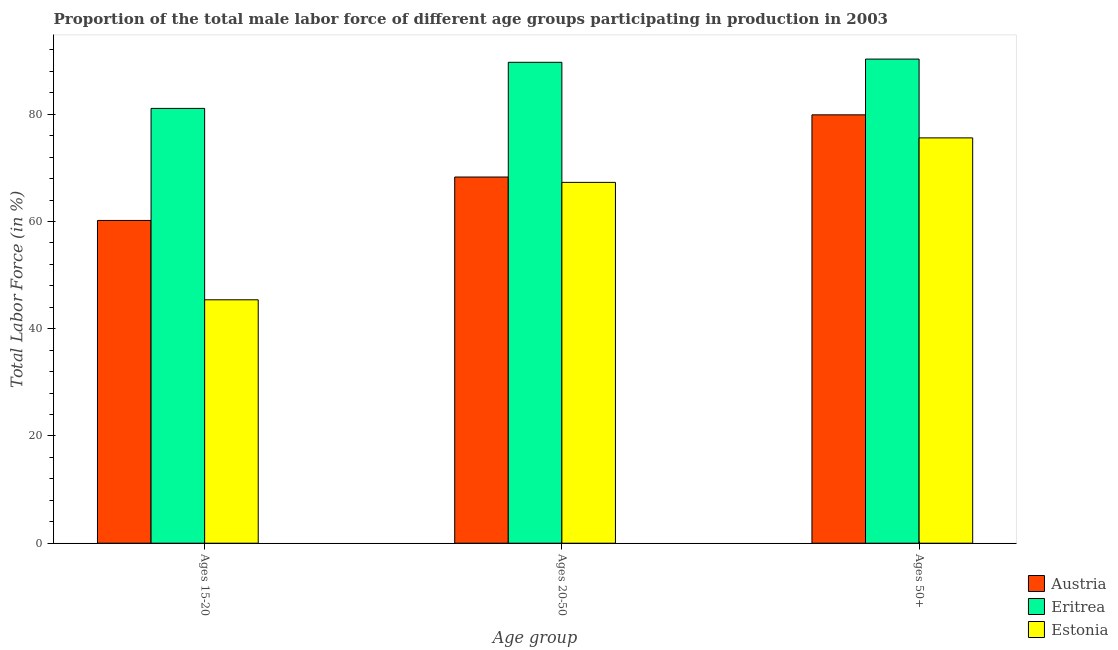How many different coloured bars are there?
Your answer should be very brief. 3. Are the number of bars on each tick of the X-axis equal?
Give a very brief answer. Yes. How many bars are there on the 1st tick from the left?
Your answer should be compact. 3. What is the label of the 1st group of bars from the left?
Offer a terse response. Ages 15-20. What is the percentage of male labor force within the age group 15-20 in Eritrea?
Your response must be concise. 81.1. Across all countries, what is the maximum percentage of male labor force above age 50?
Provide a short and direct response. 90.3. Across all countries, what is the minimum percentage of male labor force above age 50?
Offer a terse response. 75.6. In which country was the percentage of male labor force within the age group 20-50 maximum?
Ensure brevity in your answer.  Eritrea. In which country was the percentage of male labor force above age 50 minimum?
Your answer should be very brief. Estonia. What is the total percentage of male labor force within the age group 15-20 in the graph?
Offer a very short reply. 186.7. What is the difference between the percentage of male labor force within the age group 20-50 in Austria and that in Eritrea?
Keep it short and to the point. -21.4. What is the difference between the percentage of male labor force within the age group 15-20 in Estonia and the percentage of male labor force within the age group 20-50 in Eritrea?
Your answer should be very brief. -44.3. What is the average percentage of male labor force within the age group 20-50 per country?
Offer a very short reply. 75.1. What is the difference between the percentage of male labor force within the age group 20-50 and percentage of male labor force within the age group 15-20 in Eritrea?
Keep it short and to the point. 8.6. In how many countries, is the percentage of male labor force within the age group 15-20 greater than 40 %?
Keep it short and to the point. 3. What is the ratio of the percentage of male labor force within the age group 15-20 in Eritrea to that in Estonia?
Keep it short and to the point. 1.79. Is the percentage of male labor force within the age group 20-50 in Estonia less than that in Eritrea?
Your response must be concise. Yes. What is the difference between the highest and the second highest percentage of male labor force above age 50?
Your answer should be compact. 10.4. What is the difference between the highest and the lowest percentage of male labor force above age 50?
Ensure brevity in your answer.  14.7. What does the 2nd bar from the left in Ages 15-20 represents?
Offer a very short reply. Eritrea. What does the 2nd bar from the right in Ages 20-50 represents?
Offer a terse response. Eritrea. Is it the case that in every country, the sum of the percentage of male labor force within the age group 15-20 and percentage of male labor force within the age group 20-50 is greater than the percentage of male labor force above age 50?
Make the answer very short. Yes. How many bars are there?
Provide a short and direct response. 9. Are all the bars in the graph horizontal?
Your answer should be compact. No. How many countries are there in the graph?
Your answer should be compact. 3. What is the difference between two consecutive major ticks on the Y-axis?
Give a very brief answer. 20. How many legend labels are there?
Ensure brevity in your answer.  3. What is the title of the graph?
Offer a very short reply. Proportion of the total male labor force of different age groups participating in production in 2003. Does "Saudi Arabia" appear as one of the legend labels in the graph?
Provide a short and direct response. No. What is the label or title of the X-axis?
Ensure brevity in your answer.  Age group. What is the label or title of the Y-axis?
Give a very brief answer. Total Labor Force (in %). What is the Total Labor Force (in %) in Austria in Ages 15-20?
Your response must be concise. 60.2. What is the Total Labor Force (in %) of Eritrea in Ages 15-20?
Give a very brief answer. 81.1. What is the Total Labor Force (in %) of Estonia in Ages 15-20?
Your answer should be compact. 45.4. What is the Total Labor Force (in %) of Austria in Ages 20-50?
Provide a short and direct response. 68.3. What is the Total Labor Force (in %) of Eritrea in Ages 20-50?
Your answer should be compact. 89.7. What is the Total Labor Force (in %) of Estonia in Ages 20-50?
Give a very brief answer. 67.3. What is the Total Labor Force (in %) in Austria in Ages 50+?
Give a very brief answer. 79.9. What is the Total Labor Force (in %) in Eritrea in Ages 50+?
Offer a terse response. 90.3. What is the Total Labor Force (in %) of Estonia in Ages 50+?
Your answer should be compact. 75.6. Across all Age group, what is the maximum Total Labor Force (in %) of Austria?
Give a very brief answer. 79.9. Across all Age group, what is the maximum Total Labor Force (in %) of Eritrea?
Your answer should be very brief. 90.3. Across all Age group, what is the maximum Total Labor Force (in %) of Estonia?
Give a very brief answer. 75.6. Across all Age group, what is the minimum Total Labor Force (in %) in Austria?
Provide a succinct answer. 60.2. Across all Age group, what is the minimum Total Labor Force (in %) of Eritrea?
Your answer should be very brief. 81.1. Across all Age group, what is the minimum Total Labor Force (in %) in Estonia?
Your answer should be compact. 45.4. What is the total Total Labor Force (in %) of Austria in the graph?
Your response must be concise. 208.4. What is the total Total Labor Force (in %) in Eritrea in the graph?
Your answer should be compact. 261.1. What is the total Total Labor Force (in %) in Estonia in the graph?
Make the answer very short. 188.3. What is the difference between the Total Labor Force (in %) of Austria in Ages 15-20 and that in Ages 20-50?
Provide a short and direct response. -8.1. What is the difference between the Total Labor Force (in %) in Eritrea in Ages 15-20 and that in Ages 20-50?
Provide a succinct answer. -8.6. What is the difference between the Total Labor Force (in %) of Estonia in Ages 15-20 and that in Ages 20-50?
Your response must be concise. -21.9. What is the difference between the Total Labor Force (in %) in Austria in Ages 15-20 and that in Ages 50+?
Provide a short and direct response. -19.7. What is the difference between the Total Labor Force (in %) in Estonia in Ages 15-20 and that in Ages 50+?
Make the answer very short. -30.2. What is the difference between the Total Labor Force (in %) in Austria in Ages 15-20 and the Total Labor Force (in %) in Eritrea in Ages 20-50?
Your answer should be very brief. -29.5. What is the difference between the Total Labor Force (in %) of Eritrea in Ages 15-20 and the Total Labor Force (in %) of Estonia in Ages 20-50?
Provide a succinct answer. 13.8. What is the difference between the Total Labor Force (in %) in Austria in Ages 15-20 and the Total Labor Force (in %) in Eritrea in Ages 50+?
Give a very brief answer. -30.1. What is the difference between the Total Labor Force (in %) of Austria in Ages 15-20 and the Total Labor Force (in %) of Estonia in Ages 50+?
Offer a terse response. -15.4. What is the difference between the Total Labor Force (in %) in Austria in Ages 20-50 and the Total Labor Force (in %) in Eritrea in Ages 50+?
Provide a succinct answer. -22. What is the average Total Labor Force (in %) in Austria per Age group?
Give a very brief answer. 69.47. What is the average Total Labor Force (in %) in Eritrea per Age group?
Provide a short and direct response. 87.03. What is the average Total Labor Force (in %) in Estonia per Age group?
Your answer should be compact. 62.77. What is the difference between the Total Labor Force (in %) of Austria and Total Labor Force (in %) of Eritrea in Ages 15-20?
Your response must be concise. -20.9. What is the difference between the Total Labor Force (in %) of Eritrea and Total Labor Force (in %) of Estonia in Ages 15-20?
Make the answer very short. 35.7. What is the difference between the Total Labor Force (in %) of Austria and Total Labor Force (in %) of Eritrea in Ages 20-50?
Offer a very short reply. -21.4. What is the difference between the Total Labor Force (in %) of Eritrea and Total Labor Force (in %) of Estonia in Ages 20-50?
Offer a very short reply. 22.4. What is the difference between the Total Labor Force (in %) in Austria and Total Labor Force (in %) in Eritrea in Ages 50+?
Your answer should be compact. -10.4. What is the difference between the Total Labor Force (in %) in Austria and Total Labor Force (in %) in Estonia in Ages 50+?
Keep it short and to the point. 4.3. What is the ratio of the Total Labor Force (in %) in Austria in Ages 15-20 to that in Ages 20-50?
Provide a short and direct response. 0.88. What is the ratio of the Total Labor Force (in %) of Eritrea in Ages 15-20 to that in Ages 20-50?
Offer a terse response. 0.9. What is the ratio of the Total Labor Force (in %) in Estonia in Ages 15-20 to that in Ages 20-50?
Your answer should be compact. 0.67. What is the ratio of the Total Labor Force (in %) of Austria in Ages 15-20 to that in Ages 50+?
Your answer should be very brief. 0.75. What is the ratio of the Total Labor Force (in %) of Eritrea in Ages 15-20 to that in Ages 50+?
Ensure brevity in your answer.  0.9. What is the ratio of the Total Labor Force (in %) in Estonia in Ages 15-20 to that in Ages 50+?
Make the answer very short. 0.6. What is the ratio of the Total Labor Force (in %) of Austria in Ages 20-50 to that in Ages 50+?
Keep it short and to the point. 0.85. What is the ratio of the Total Labor Force (in %) of Estonia in Ages 20-50 to that in Ages 50+?
Your answer should be compact. 0.89. What is the difference between the highest and the second highest Total Labor Force (in %) of Austria?
Make the answer very short. 11.6. What is the difference between the highest and the lowest Total Labor Force (in %) of Austria?
Your response must be concise. 19.7. What is the difference between the highest and the lowest Total Labor Force (in %) in Estonia?
Your response must be concise. 30.2. 